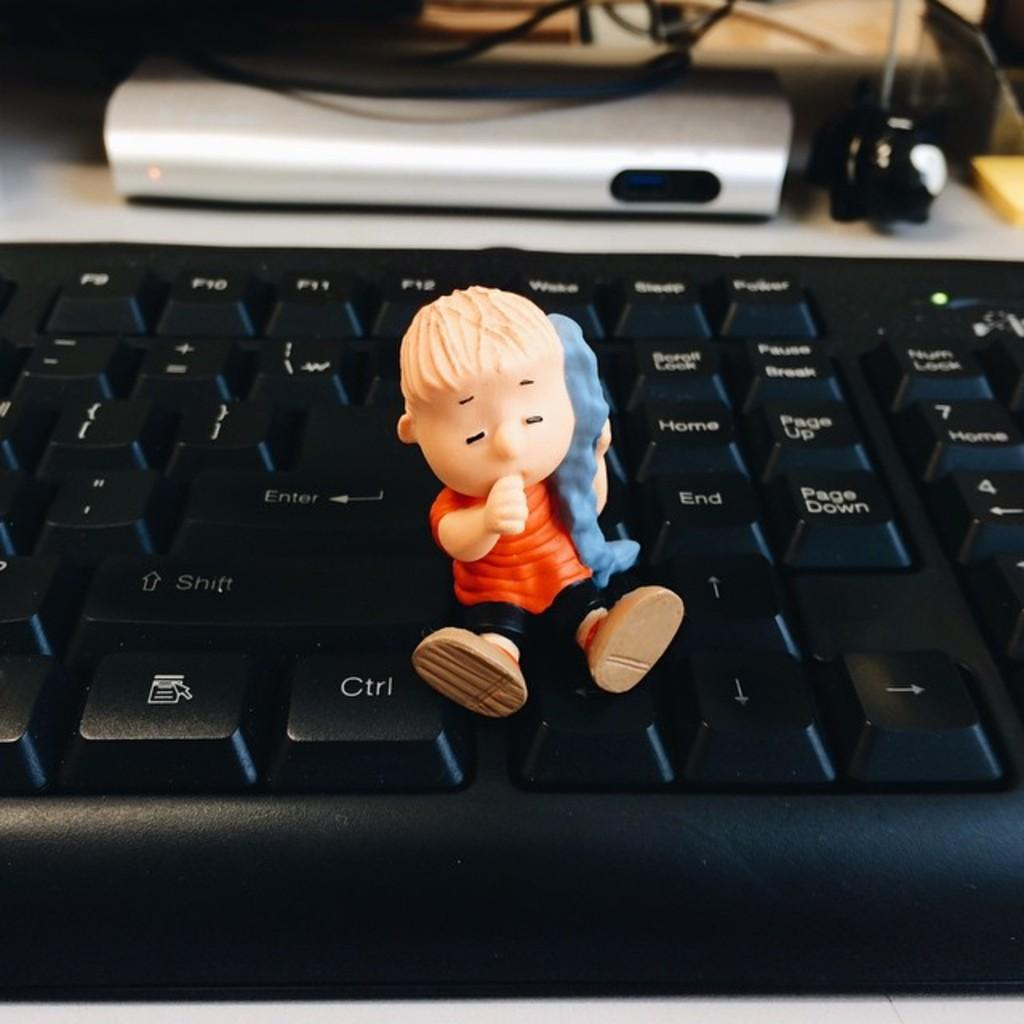<image>
Render a clear and concise summary of the photo. The small cartoon character children's toy sits on the keyboard like he's going to hit the [Ctrl] like a gas pedal. 